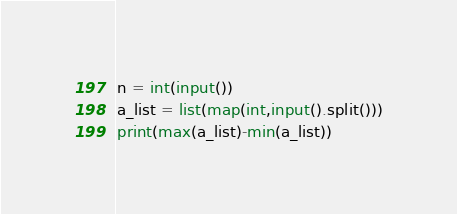Convert code to text. <code><loc_0><loc_0><loc_500><loc_500><_Python_>n = int(input())
a_list = list(map(int,input().split()))
print(max(a_list)-min(a_list))</code> 